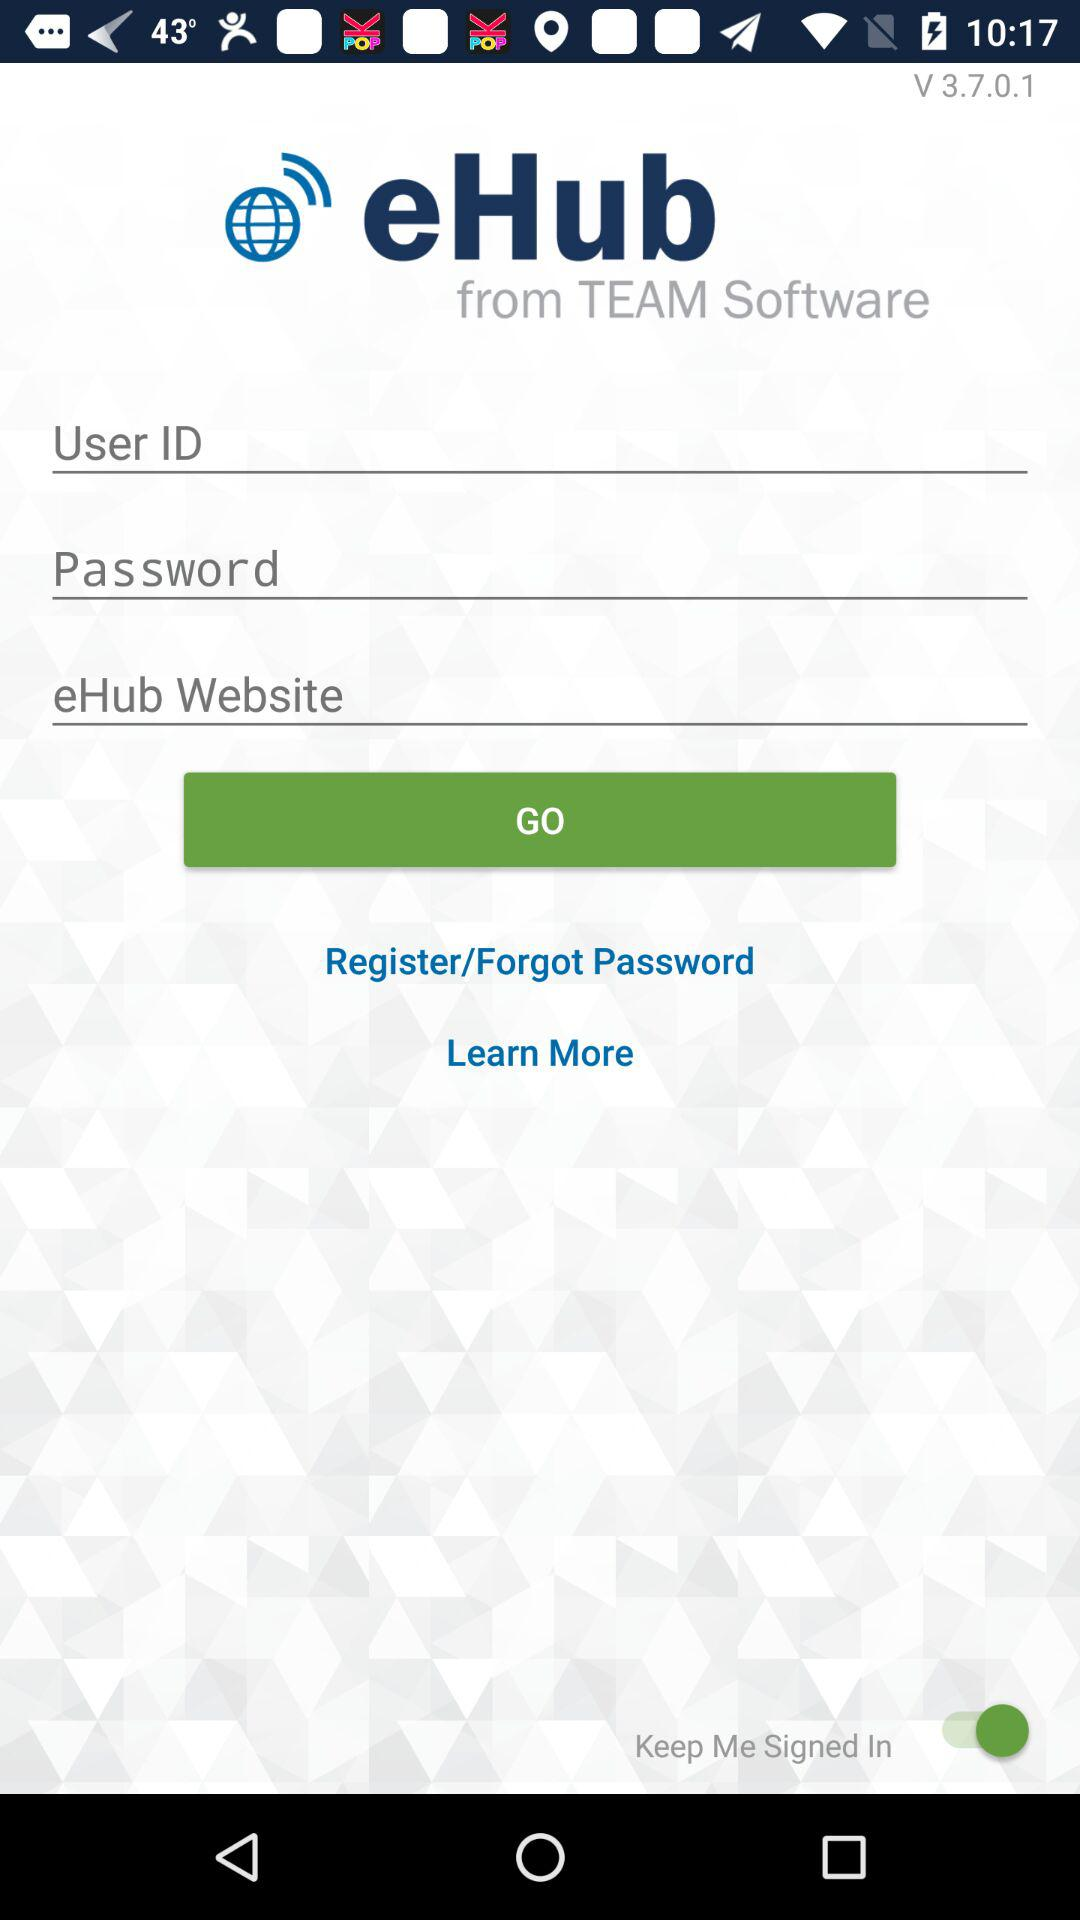What is the application name? The application name is "eHUB". 